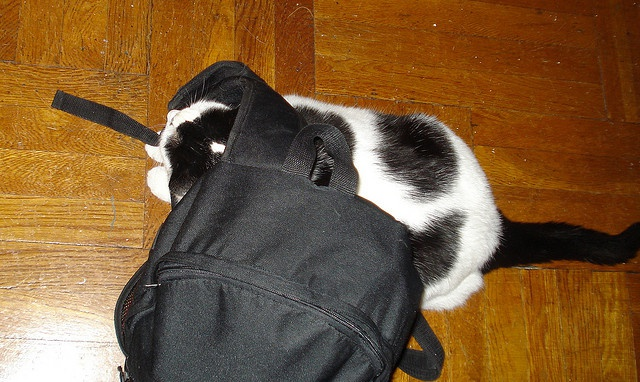Describe the objects in this image and their specific colors. I can see backpack in olive, gray, black, and purple tones and cat in olive, black, white, gray, and darkgray tones in this image. 